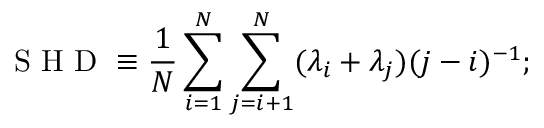Convert formula to latex. <formula><loc_0><loc_0><loc_500><loc_500>S H D \equiv \frac { 1 } { N } \sum _ { i = 1 } ^ { N } \sum _ { j = i + 1 } ^ { N } ( \lambda _ { i } + \lambda _ { j } ) ( j - i ) ^ { - 1 } ;</formula> 